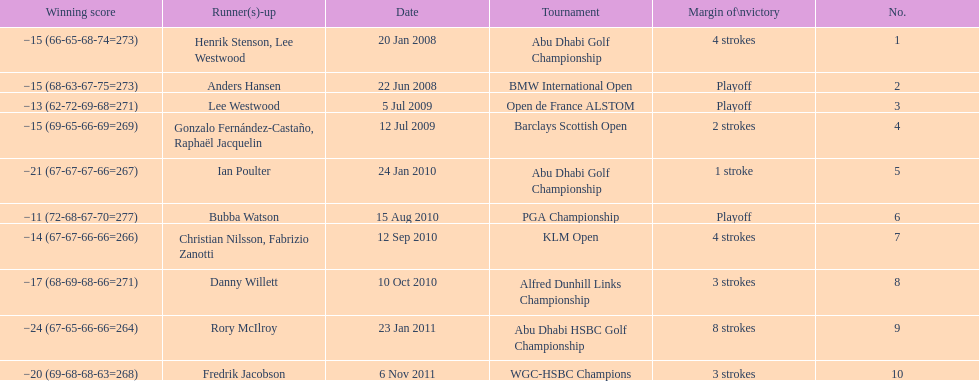How many more strokes were in the klm open than the barclays scottish open? 2 strokes. 